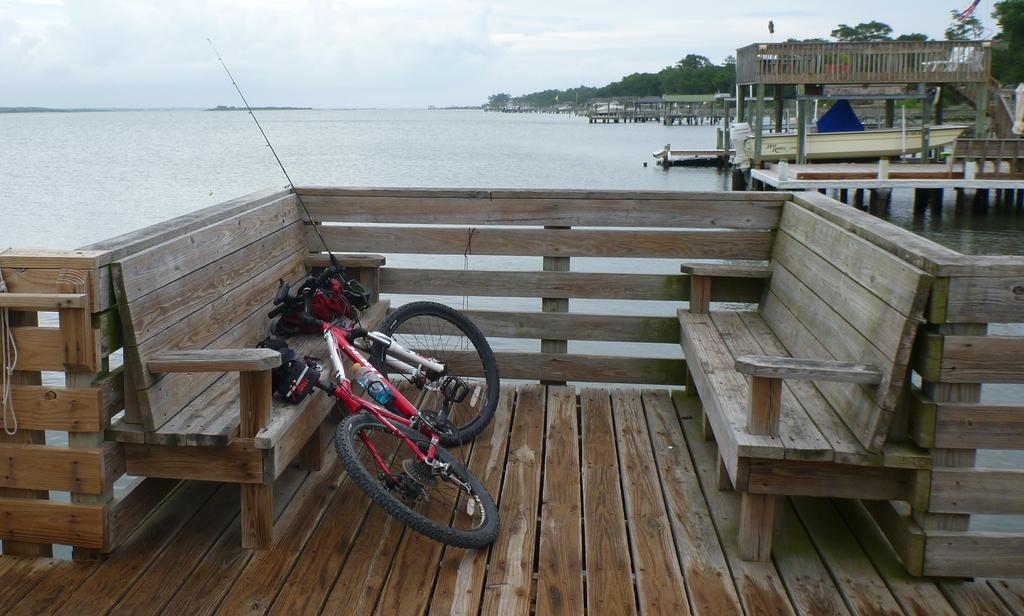What type of view is shown in the image? The image depicts a sea view point. What kind of object can be seen near the sea? There is a wooden chair-like object in the image. Are there any other objects visible in the image? Yes, there is a bicycle in the image. What type of muscle is being exercised by the person riding the bicycle in the image? There is no person riding the bicycle in the image, so it is not possible to determine which muscles might be exercised. 